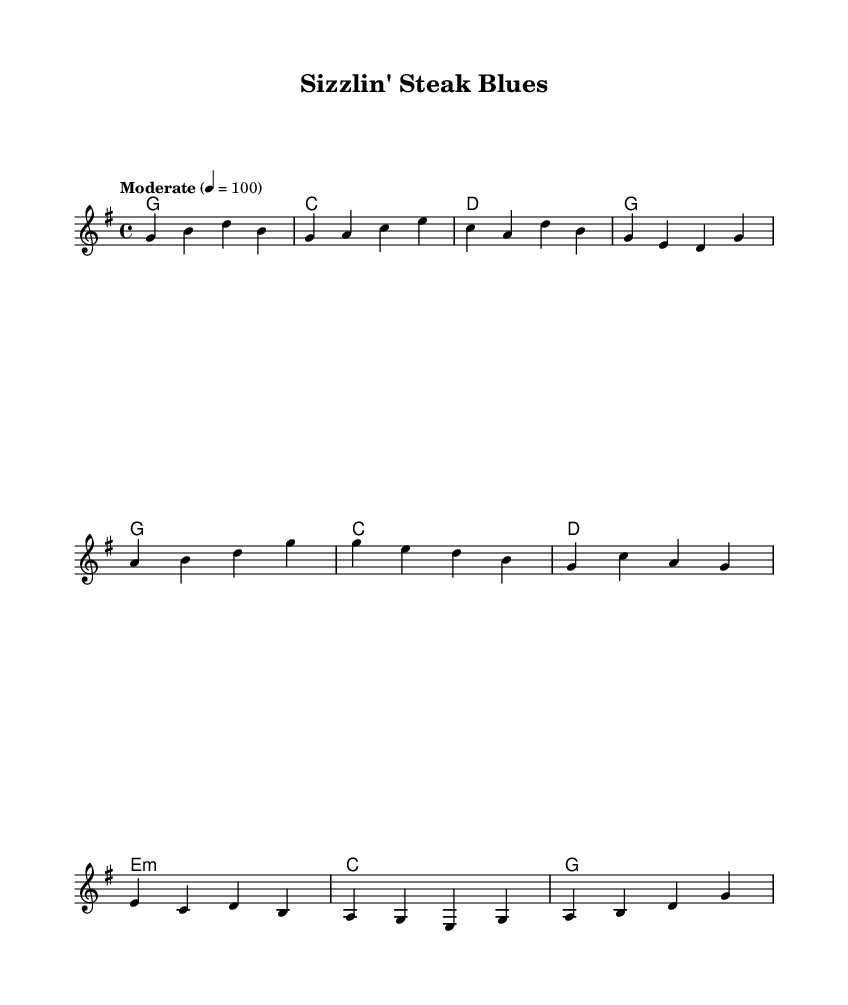What is the key signature of this music? The key signature is G major, which has one sharp (F#).
Answer: G major What is the time signature of this music? The time signature is indicated at the beginning of the score as 4/4.
Answer: 4/4 What is the tempo marking for this piece? The tempo marking is "Moderate" at a speed of 100 beats per minute.
Answer: Moderate 4 = 100 How many measures are there in the verse section? The verse consists of four measures, as indicated by the notation.
Answer: Four measures What type of chord is used in the chorus after the first two bars? The chord used after the first two bars in the chorus is E minor, as shown in the chord progression.
Answer: E minor How many lines of lyrics are present in the entire score? There are two lines of lyrics in the score, corresponding to the verse and the chorus.
Answer: Two lines What culinary theme does this musical piece celebrate? The music celebrates steakhouse culture and cuisine, reflecting a traditional meat-based culinary experience.
Answer: Steakhouse culture 